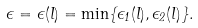<formula> <loc_0><loc_0><loc_500><loc_500>\epsilon = \epsilon ( l ) = \min \{ \epsilon _ { 1 } ( l ) , \epsilon _ { 2 } ( l ) \} .</formula> 